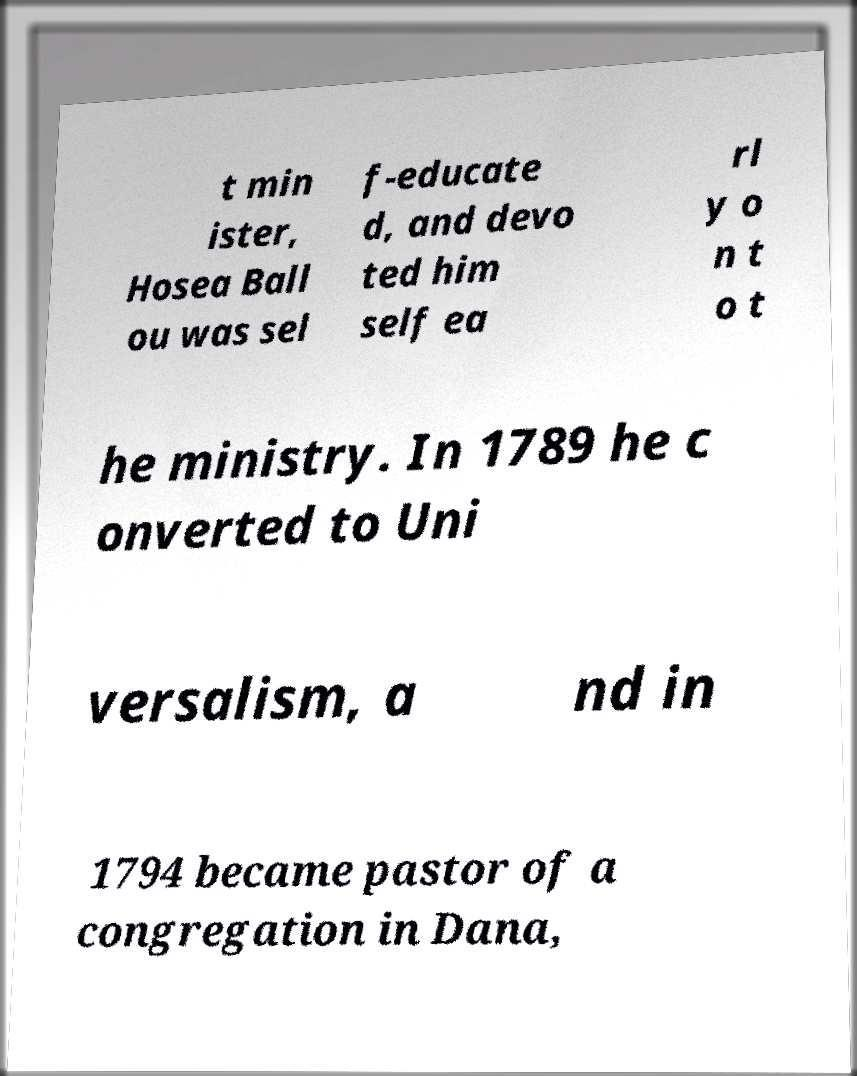Can you accurately transcribe the text from the provided image for me? t min ister, Hosea Ball ou was sel f-educate d, and devo ted him self ea rl y o n t o t he ministry. In 1789 he c onverted to Uni versalism, a nd in 1794 became pastor of a congregation in Dana, 